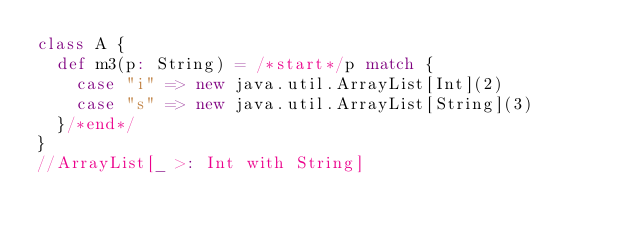Convert code to text. <code><loc_0><loc_0><loc_500><loc_500><_Scala_>class A {
  def m3(p: String) = /*start*/p match {
    case "i" => new java.util.ArrayList[Int](2)
    case "s" => new java.util.ArrayList[String](3)
  }/*end*/
}
//ArrayList[_ >: Int with String]</code> 